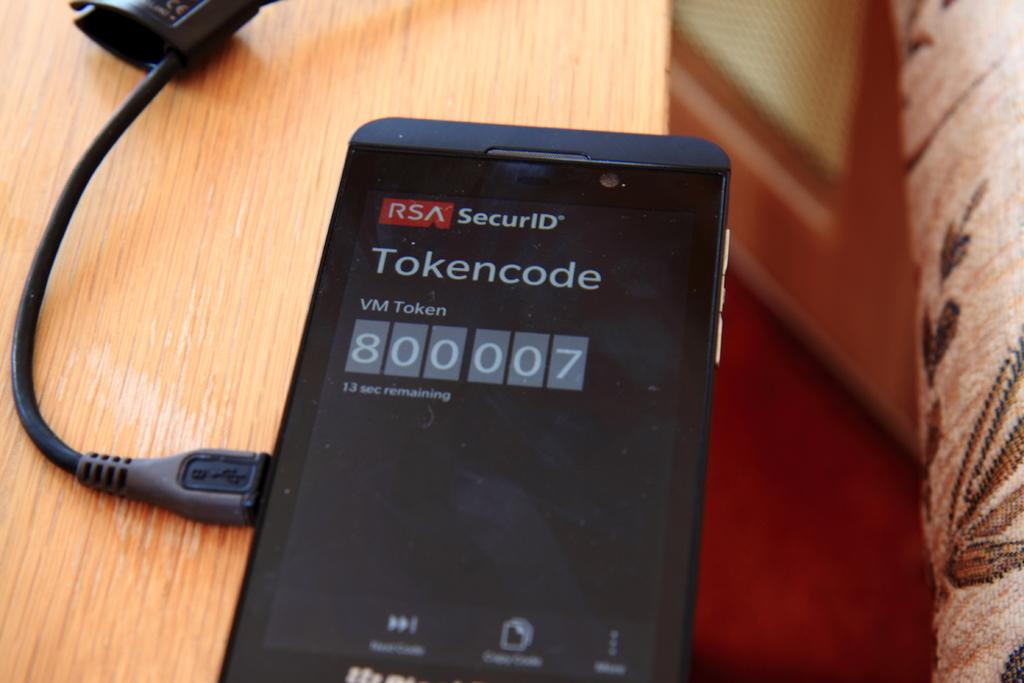<image>
Share a concise interpretation of the image provided. a cell phone with screen reading Tokencode is plugged into a charger 